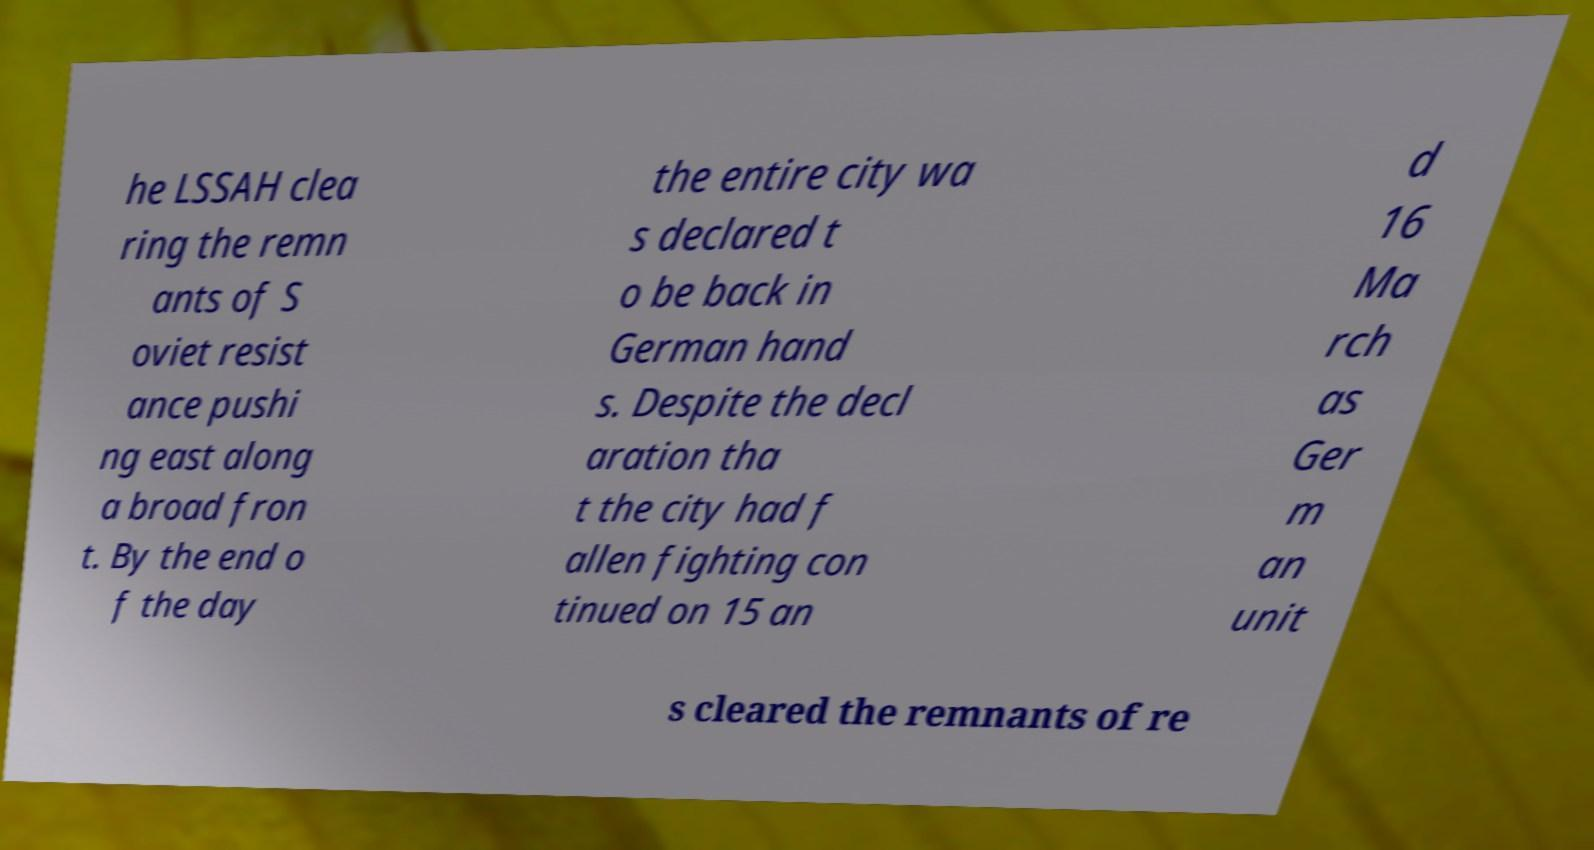There's text embedded in this image that I need extracted. Can you transcribe it verbatim? he LSSAH clea ring the remn ants of S oviet resist ance pushi ng east along a broad fron t. By the end o f the day the entire city wa s declared t o be back in German hand s. Despite the decl aration tha t the city had f allen fighting con tinued on 15 an d 16 Ma rch as Ger m an unit s cleared the remnants of re 